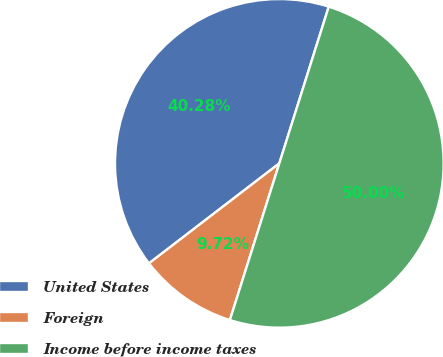Convert chart to OTSL. <chart><loc_0><loc_0><loc_500><loc_500><pie_chart><fcel>United States<fcel>Foreign<fcel>Income before income taxes<nl><fcel>40.28%<fcel>9.72%<fcel>50.0%<nl></chart> 